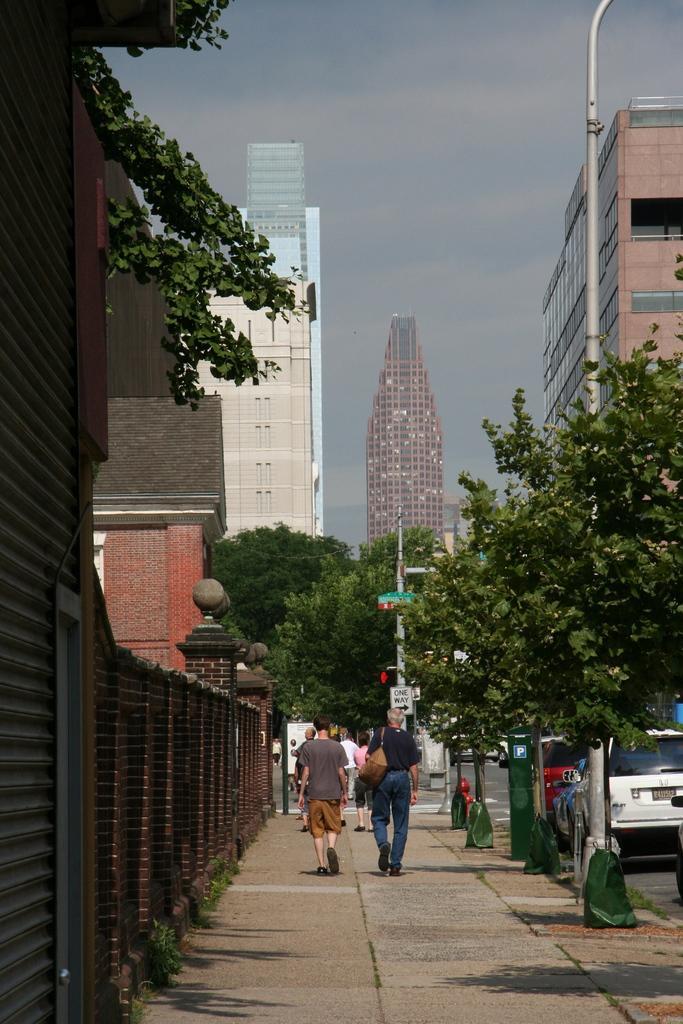Can you describe this image briefly? In this image we can see a sidewalk. On the sidewalk few people are walking. On the left side there is a wall, tree and buildings. On the right side there are trees, poles and vehicles on the road. Also there are buildings. In the background there is sky. 